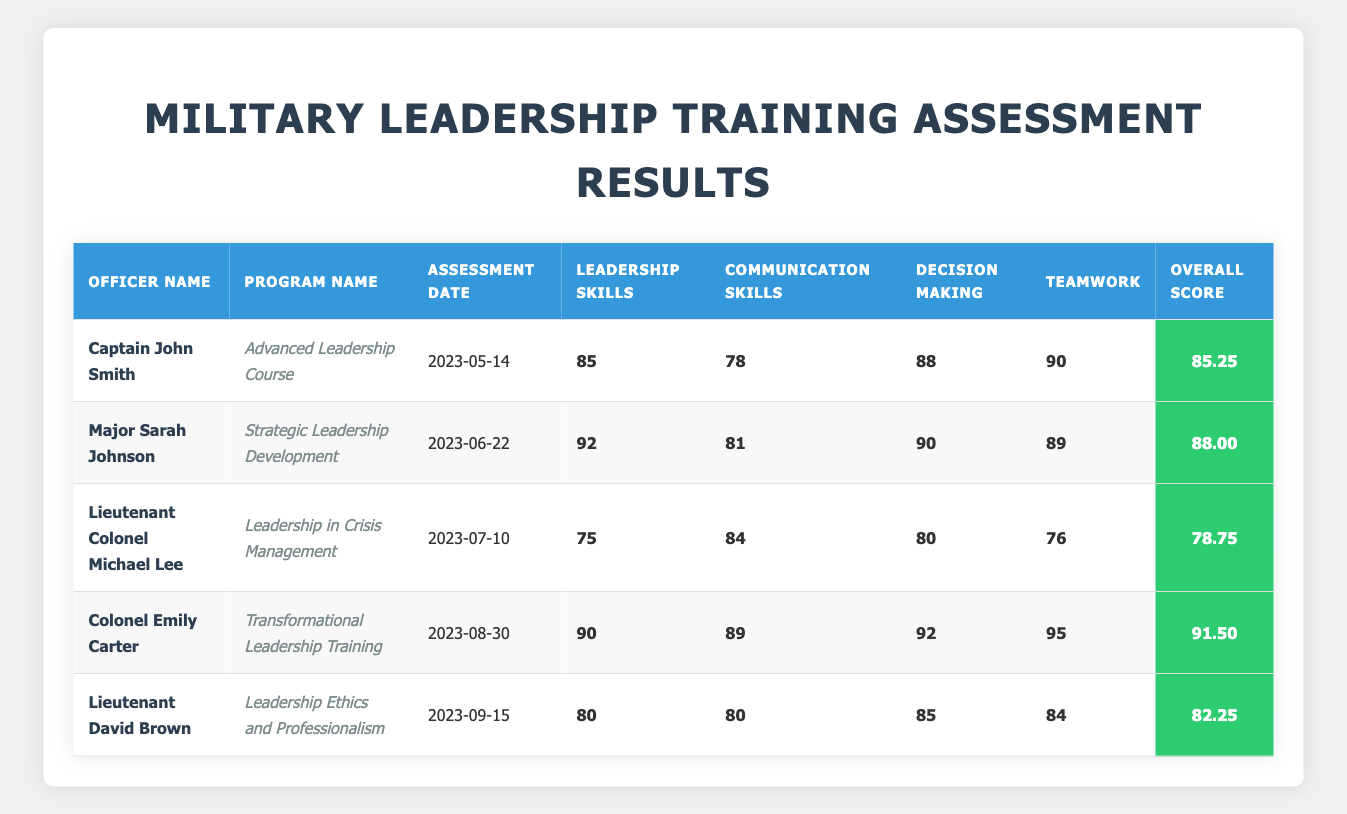What is the overall score of Colonel Emily Carter? Colonel Emily Carter's overall score can be found in the last column of her row. Her row lists an overall score of 91.50.
Answer: 91.50 Which officer scored the highest in decision-making skills? By examining the decision-making scores for all officers, Major Sarah Johnson has the highest score at 90.
Answer: Major Sarah Johnson What is the average leadership skills score of the officers? The leadership skills scores are 85, 92, 75, 90, and 80. Summing these gives 85 + 92 + 75 + 90 + 80 = 422. There are 5 officers, so the average is 422/5 = 84.4.
Answer: 84.4 Did Lieutenant Colonel Michael Lee score above 80 in teamwork skills? The teamwork score for Lieutenant Colonel Michael Lee is 76, which is below 80.
Answer: No What is the overall score difference between Captain John Smith and Colonel Emily Carter? Captain John Smith has an overall score of 85.25, while Colonel Emily Carter has 91.50. The difference is 91.50 - 85.25 = 6.25.
Answer: 6.25 Which officer had the lowest overall score and what was it? Comparing all overall scores, Lieutenant Colonel Michael Lee has the lowest overall score of 78.75.
Answer: Lieutenant Colonel Michael Lee, 78.75 What percentage of the maximum score did Major Sarah Johnson achieve in communication skills (assuming the maximum score is 100)? Major Sarah Johnson scored 81 in communication skills. Calculating the percentage, (81/100) * 100 = 81%.
Answer: 81% How many officers scored above 85 in overall performance? The officers with overall scores above 85 are Major Sarah Johnson (88.00), Colonel Emily Carter (91.50), and Captain John Smith (85.25). This totals to 3 officers.
Answer: 3 Which program had the highest average score across all categories? To determine this, calculate the average for each program: Advanced Leadership Course (85.25), Strategic Leadership Development (88.00), Leadership in Crisis Management (78.75), Transformational Leadership Training (91.50), Leadership Ethics and Professionalism (82.25). The highest average is from Transformational Leadership Training, which is 91.50.
Answer: Transformational Leadership Training 